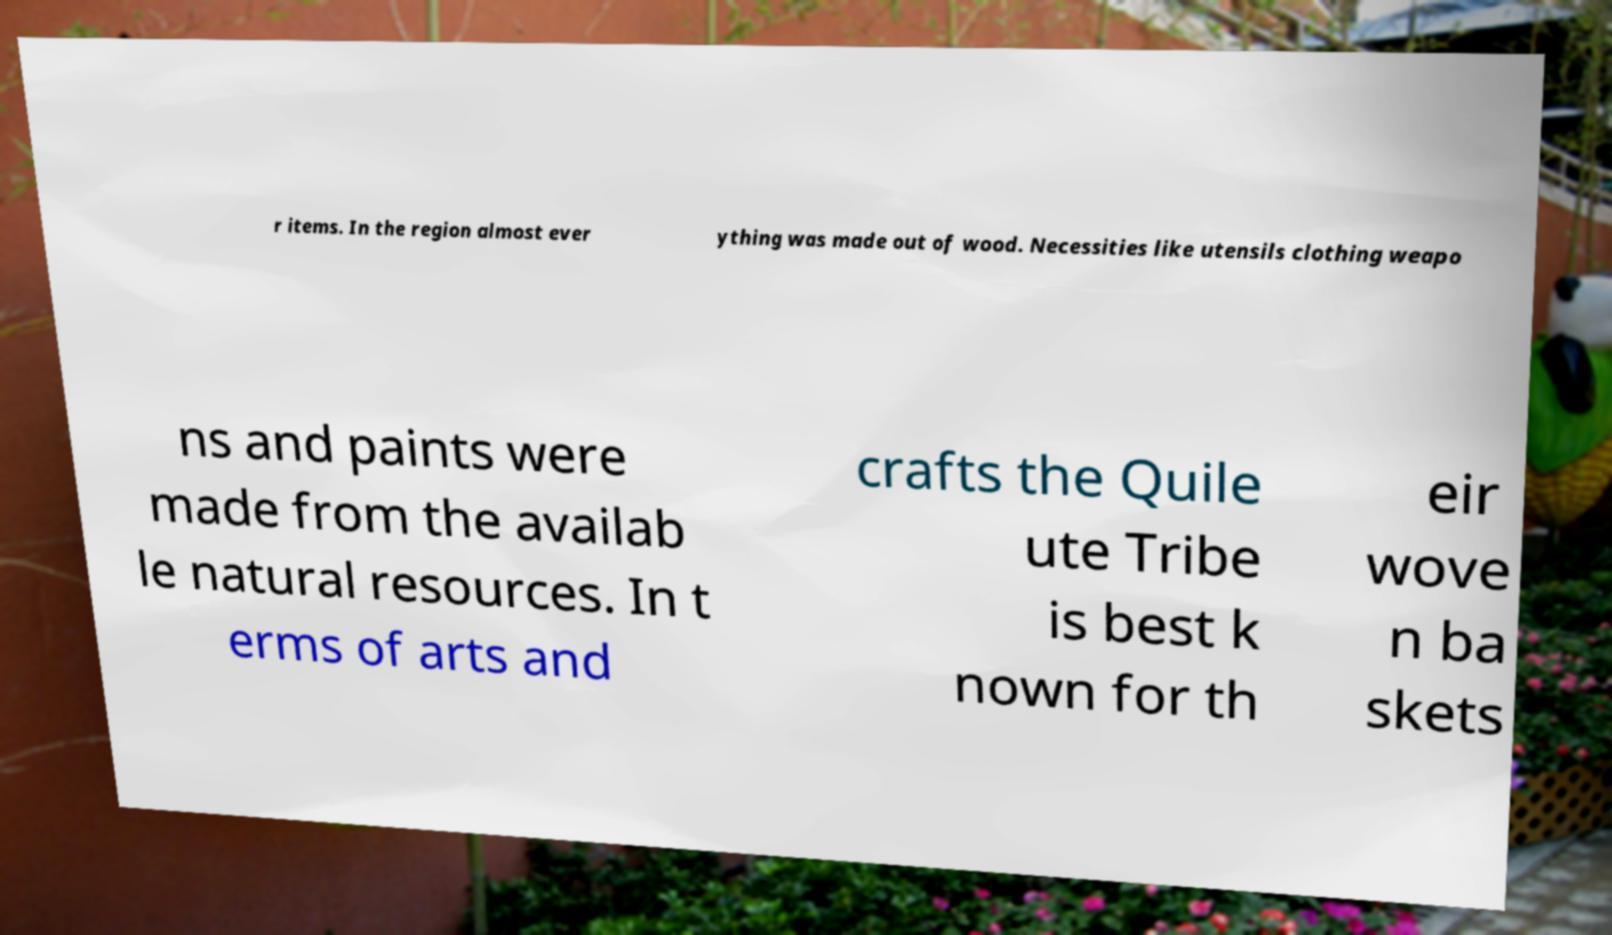Could you extract and type out the text from this image? r items. In the region almost ever ything was made out of wood. Necessities like utensils clothing weapo ns and paints were made from the availab le natural resources. In t erms of arts and crafts the Quile ute Tribe is best k nown for th eir wove n ba skets 